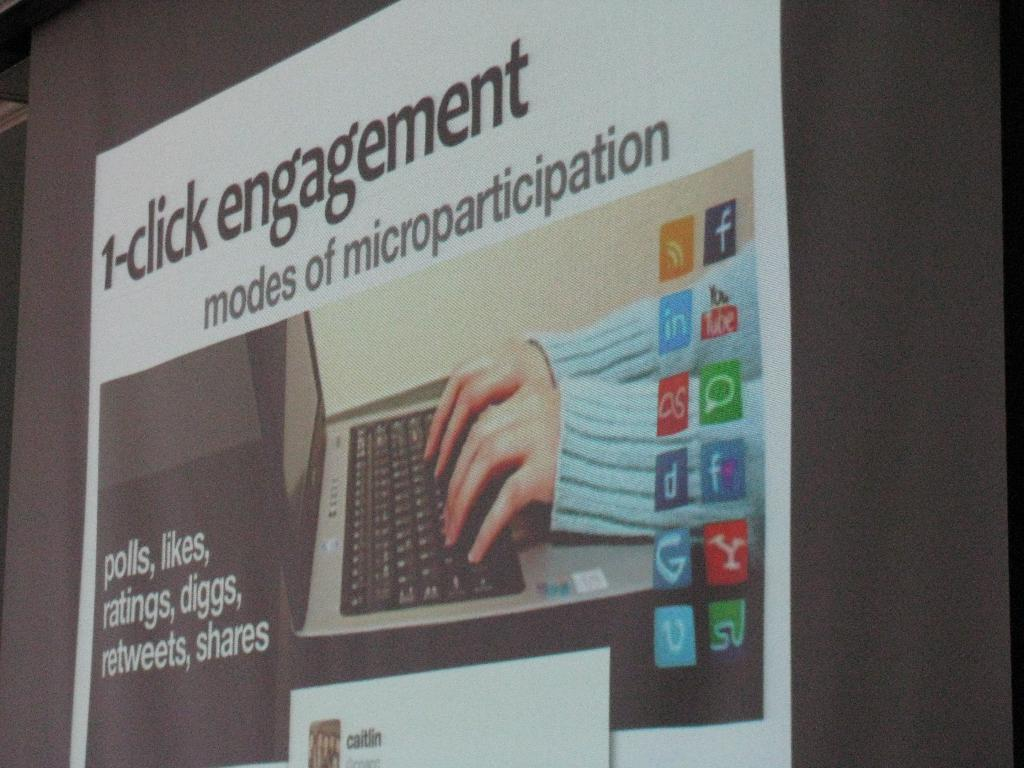<image>
Relay a brief, clear account of the picture shown. Information for modes of microparticipation called 1-click engagement. 